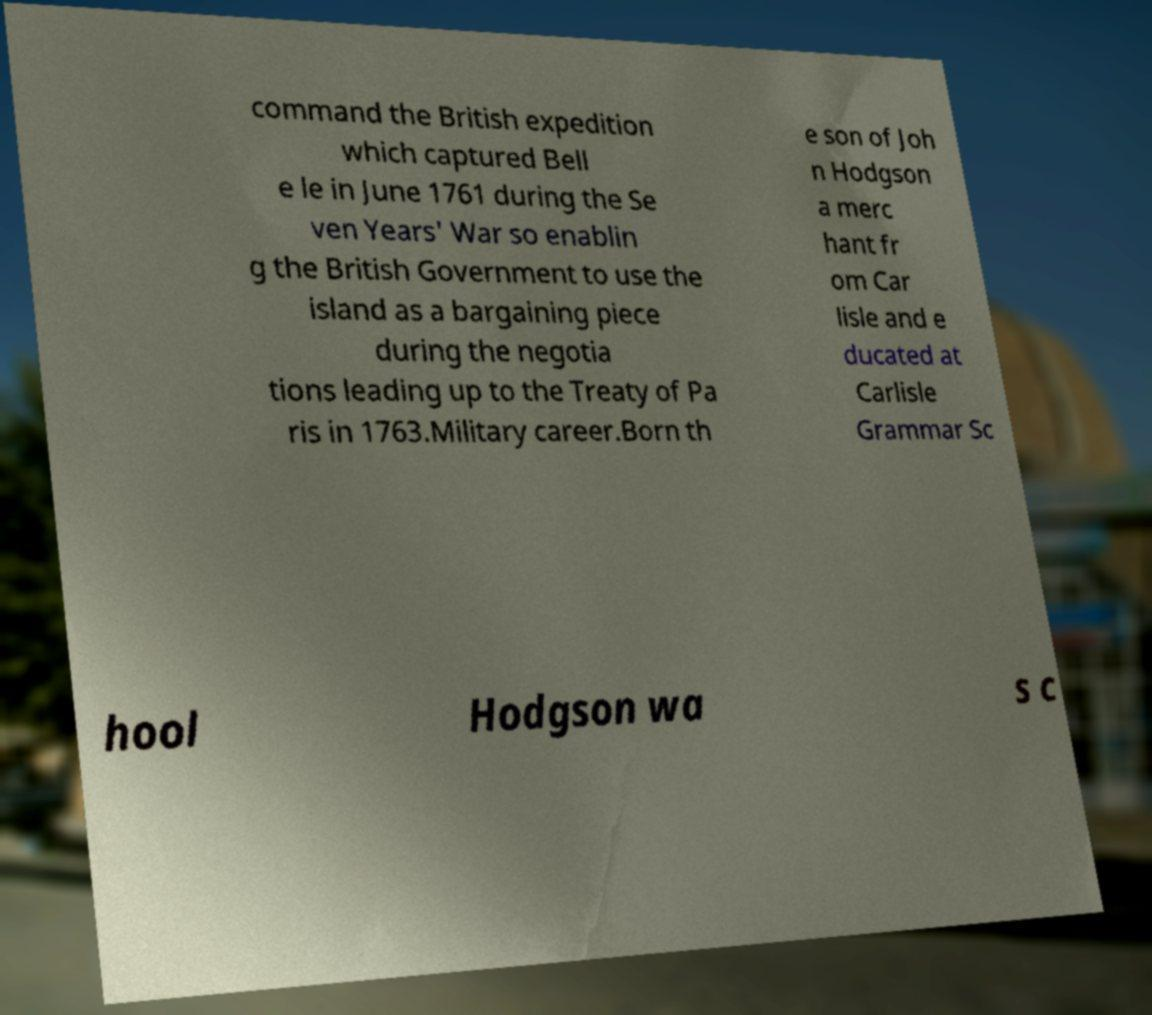Please read and relay the text visible in this image. What does it say? command the British expedition which captured Bell e le in June 1761 during the Se ven Years' War so enablin g the British Government to use the island as a bargaining piece during the negotia tions leading up to the Treaty of Pa ris in 1763.Military career.Born th e son of Joh n Hodgson a merc hant fr om Car lisle and e ducated at Carlisle Grammar Sc hool Hodgson wa s c 